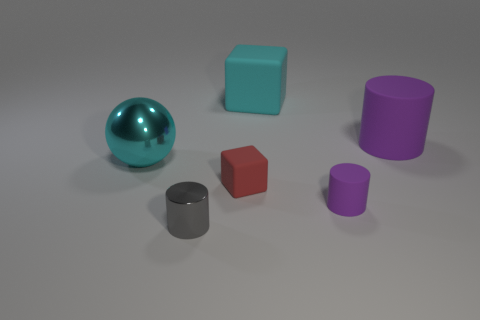Add 3 small brown metallic things. How many objects exist? 9 Subtract all blocks. How many objects are left? 4 Add 5 tiny blocks. How many tiny blocks are left? 6 Add 5 purple rubber spheres. How many purple rubber spheres exist? 5 Subtract 0 red cylinders. How many objects are left? 6 Subtract all cyan matte objects. Subtract all matte cylinders. How many objects are left? 3 